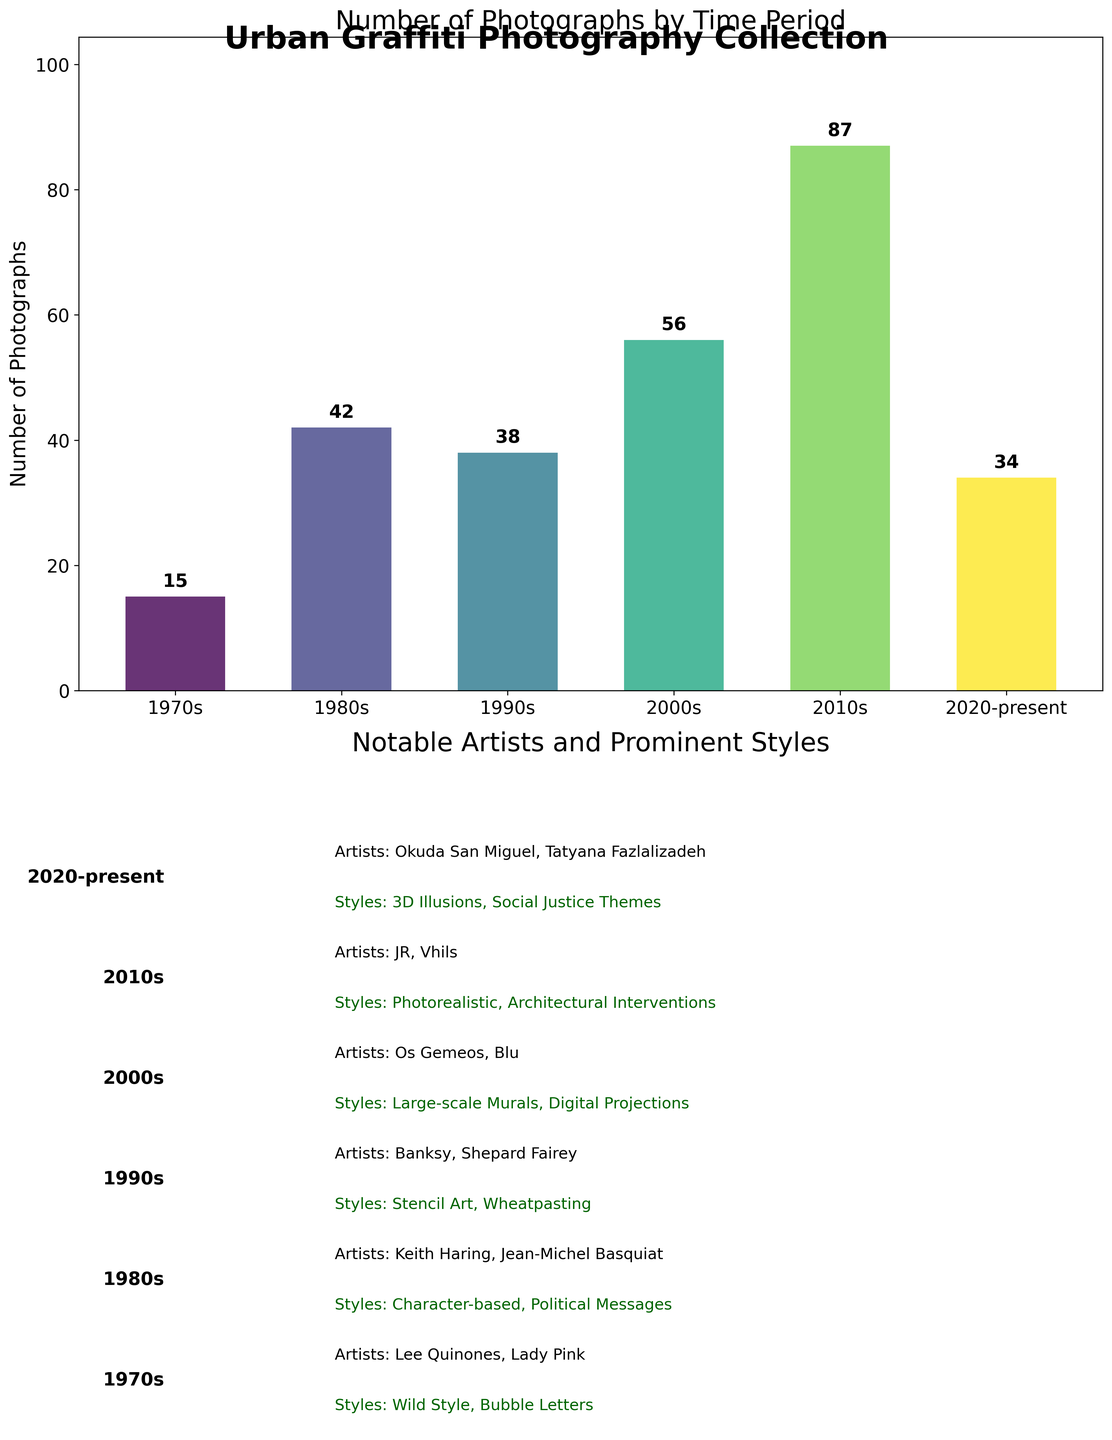What's the total number of graffiti photographs in the collection? Sum the number of photographs from each time period: 15 (1970s) + 42 (1980s) + 38 (1990s) + 56 (2000s) + 87 (2010s) + 34 (2020-present) = 272
Answer: 272 Which time period has the highest number of graffiti photographs? Compare the number of photographs across all time periods. The highest value is 87 in the 2010s.
Answer: 2010s What are the prominent styles of the 1980s? Look at the text associated with the 1980s in Subplot 2, which lists "Character-based" and "Political Messages".
Answer: Character-based; Political Messages How many more photographs are there in the 2010s compared to the 1970s? Subtract the number of photographs in the 1970s from the number in the 2010s: 87 (2010s) - 15 (1970s) = 72
Answer: 72 Which notable artists are mentioned for the 2000s? Refer to the associated text for the 2000s in Subplot 2, which lists "Os Gemeos" and "Blu".
Answer: Os Gemeos; Blu What time periods have fewer than 40 graffiti photographs? Identify all time periods with fewer than 40 photographs: 1970s (15), 2020-present (34).
Answer: 1970s, 2020-present In which decade did the number of graffiti photographs first exceed 50? Examine the provided numbers for each decade. The 2000s is the first to exceed 50 with 56 photographs.
Answer: 2000s What's the total number of photographs in the 1980s and 1990s combined? Add the number of photographs from the 1980s and the 1990s: 42 (1980s) + 38 (1990s) = 80
Answer: 80 How do the styles of the 2010s differ from those of the 1990s? Compare the described styles: 1990s have "Stencil Art" and "Wheatpasting", while the 2010s have "Photorealistic" and "Architectural Interventions".
Answer: Photorealistic; Architectural Interventions vs. Stencil Art; Wheatpasting 